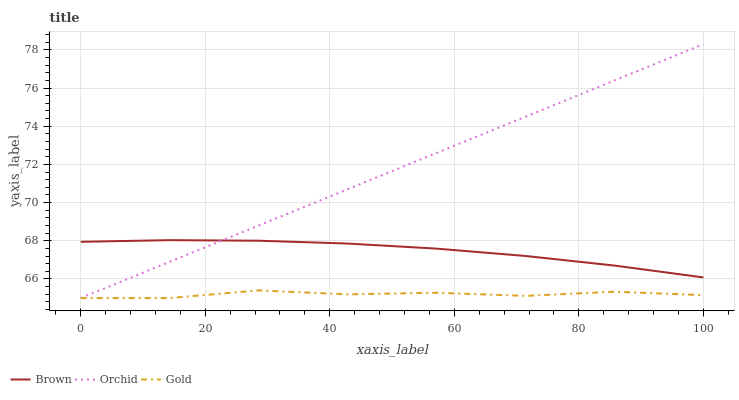Does Gold have the minimum area under the curve?
Answer yes or no. Yes. Does Orchid have the maximum area under the curve?
Answer yes or no. Yes. Does Orchid have the minimum area under the curve?
Answer yes or no. No. Does Gold have the maximum area under the curve?
Answer yes or no. No. Is Orchid the smoothest?
Answer yes or no. Yes. Is Gold the roughest?
Answer yes or no. Yes. Is Gold the smoothest?
Answer yes or no. No. Is Orchid the roughest?
Answer yes or no. No. Does Gold have the lowest value?
Answer yes or no. Yes. Does Orchid have the highest value?
Answer yes or no. Yes. Does Gold have the highest value?
Answer yes or no. No. Is Gold less than Brown?
Answer yes or no. Yes. Is Brown greater than Gold?
Answer yes or no. Yes. Does Brown intersect Orchid?
Answer yes or no. Yes. Is Brown less than Orchid?
Answer yes or no. No. Is Brown greater than Orchid?
Answer yes or no. No. Does Gold intersect Brown?
Answer yes or no. No. 